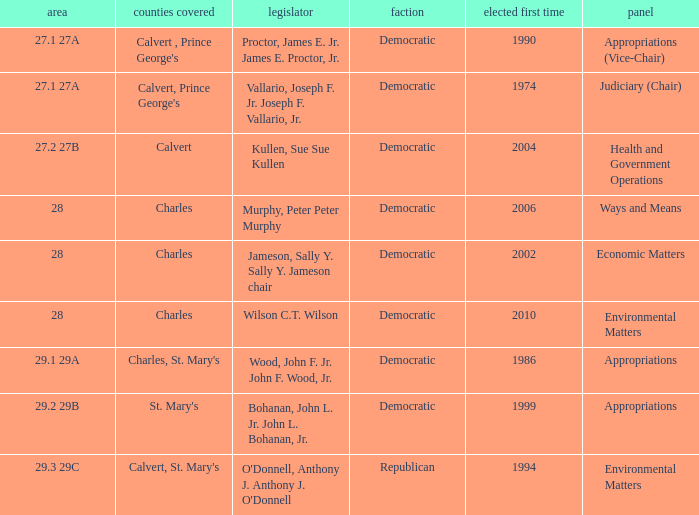Which was the district that had first elected greater than 2006 and is democratic? 28.0. 